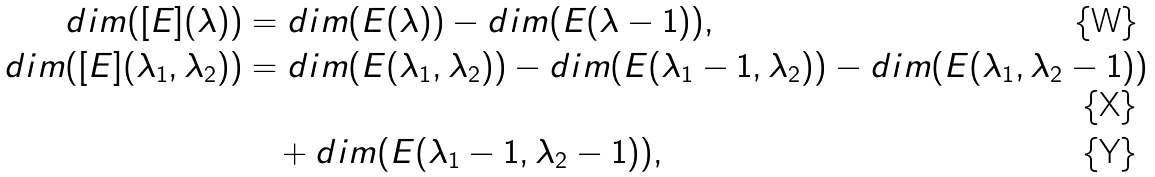<formula> <loc_0><loc_0><loc_500><loc_500>d i m ( [ E ] ( \lambda ) ) & = d i m ( E ( \lambda ) ) - d i m ( E ( \lambda - 1 ) ) , \\ d i m ( [ E ] ( \lambda _ { 1 } , \lambda _ { 2 } ) ) & = d i m ( E ( \lambda _ { 1 } , \lambda _ { 2 } ) ) - d i m ( E ( \lambda _ { 1 } - 1 , \lambda _ { 2 } ) ) - d i m ( E ( \lambda _ { 1 } , \lambda _ { 2 } - 1 ) ) \\ & \quad + d i m ( E ( \lambda _ { 1 } - 1 , \lambda _ { 2 } - 1 ) ) ,</formula> 